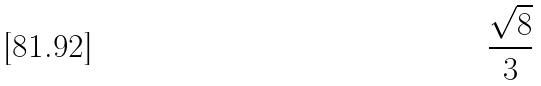<formula> <loc_0><loc_0><loc_500><loc_500>\frac { \sqrt { 8 } } { 3 }</formula> 